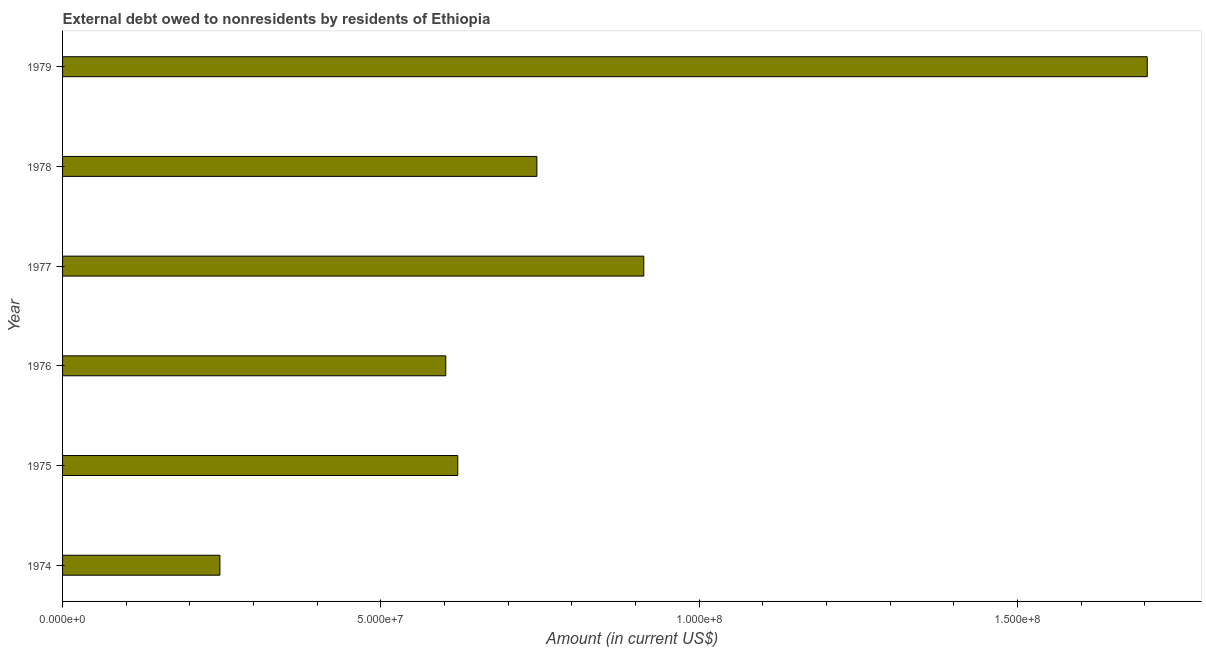What is the title of the graph?
Offer a terse response. External debt owed to nonresidents by residents of Ethiopia. What is the label or title of the Y-axis?
Give a very brief answer. Year. What is the debt in 1975?
Offer a very short reply. 6.21e+07. Across all years, what is the maximum debt?
Ensure brevity in your answer.  1.70e+08. Across all years, what is the minimum debt?
Offer a very short reply. 2.47e+07. In which year was the debt maximum?
Your answer should be compact. 1979. In which year was the debt minimum?
Your answer should be very brief. 1974. What is the sum of the debt?
Provide a short and direct response. 4.83e+08. What is the difference between the debt in 1975 and 1976?
Offer a very short reply. 1.89e+06. What is the average debt per year?
Give a very brief answer. 8.05e+07. What is the median debt?
Make the answer very short. 6.83e+07. What is the ratio of the debt in 1974 to that in 1977?
Your answer should be very brief. 0.27. What is the difference between the highest and the second highest debt?
Ensure brevity in your answer.  7.91e+07. Is the sum of the debt in 1975 and 1979 greater than the maximum debt across all years?
Give a very brief answer. Yes. What is the difference between the highest and the lowest debt?
Your response must be concise. 1.46e+08. In how many years, is the debt greater than the average debt taken over all years?
Give a very brief answer. 2. How many bars are there?
Offer a very short reply. 6. Are all the bars in the graph horizontal?
Your answer should be compact. Yes. What is the Amount (in current US$) of 1974?
Provide a short and direct response. 2.47e+07. What is the Amount (in current US$) in 1975?
Offer a terse response. 6.21e+07. What is the Amount (in current US$) of 1976?
Your answer should be compact. 6.02e+07. What is the Amount (in current US$) in 1977?
Your answer should be very brief. 9.13e+07. What is the Amount (in current US$) in 1978?
Ensure brevity in your answer.  7.45e+07. What is the Amount (in current US$) of 1979?
Provide a short and direct response. 1.70e+08. What is the difference between the Amount (in current US$) in 1974 and 1975?
Give a very brief answer. -3.74e+07. What is the difference between the Amount (in current US$) in 1974 and 1976?
Offer a terse response. -3.55e+07. What is the difference between the Amount (in current US$) in 1974 and 1977?
Your response must be concise. -6.66e+07. What is the difference between the Amount (in current US$) in 1974 and 1978?
Make the answer very short. -4.98e+07. What is the difference between the Amount (in current US$) in 1974 and 1979?
Ensure brevity in your answer.  -1.46e+08. What is the difference between the Amount (in current US$) in 1975 and 1976?
Ensure brevity in your answer.  1.89e+06. What is the difference between the Amount (in current US$) in 1975 and 1977?
Your answer should be very brief. -2.92e+07. What is the difference between the Amount (in current US$) in 1975 and 1978?
Offer a very short reply. -1.24e+07. What is the difference between the Amount (in current US$) in 1975 and 1979?
Your answer should be very brief. -1.08e+08. What is the difference between the Amount (in current US$) in 1976 and 1977?
Keep it short and to the point. -3.11e+07. What is the difference between the Amount (in current US$) in 1976 and 1978?
Make the answer very short. -1.43e+07. What is the difference between the Amount (in current US$) in 1976 and 1979?
Provide a succinct answer. -1.10e+08. What is the difference between the Amount (in current US$) in 1977 and 1978?
Ensure brevity in your answer.  1.68e+07. What is the difference between the Amount (in current US$) in 1977 and 1979?
Give a very brief answer. -7.91e+07. What is the difference between the Amount (in current US$) in 1978 and 1979?
Keep it short and to the point. -9.59e+07. What is the ratio of the Amount (in current US$) in 1974 to that in 1975?
Offer a terse response. 0.4. What is the ratio of the Amount (in current US$) in 1974 to that in 1976?
Keep it short and to the point. 0.41. What is the ratio of the Amount (in current US$) in 1974 to that in 1977?
Give a very brief answer. 0.27. What is the ratio of the Amount (in current US$) in 1974 to that in 1978?
Your answer should be very brief. 0.33. What is the ratio of the Amount (in current US$) in 1974 to that in 1979?
Make the answer very short. 0.14. What is the ratio of the Amount (in current US$) in 1975 to that in 1976?
Your answer should be compact. 1.03. What is the ratio of the Amount (in current US$) in 1975 to that in 1977?
Offer a terse response. 0.68. What is the ratio of the Amount (in current US$) in 1975 to that in 1978?
Make the answer very short. 0.83. What is the ratio of the Amount (in current US$) in 1975 to that in 1979?
Offer a very short reply. 0.36. What is the ratio of the Amount (in current US$) in 1976 to that in 1977?
Provide a succinct answer. 0.66. What is the ratio of the Amount (in current US$) in 1976 to that in 1978?
Your answer should be very brief. 0.81. What is the ratio of the Amount (in current US$) in 1976 to that in 1979?
Your response must be concise. 0.35. What is the ratio of the Amount (in current US$) in 1977 to that in 1978?
Provide a short and direct response. 1.23. What is the ratio of the Amount (in current US$) in 1977 to that in 1979?
Provide a succinct answer. 0.54. What is the ratio of the Amount (in current US$) in 1978 to that in 1979?
Provide a succinct answer. 0.44. 